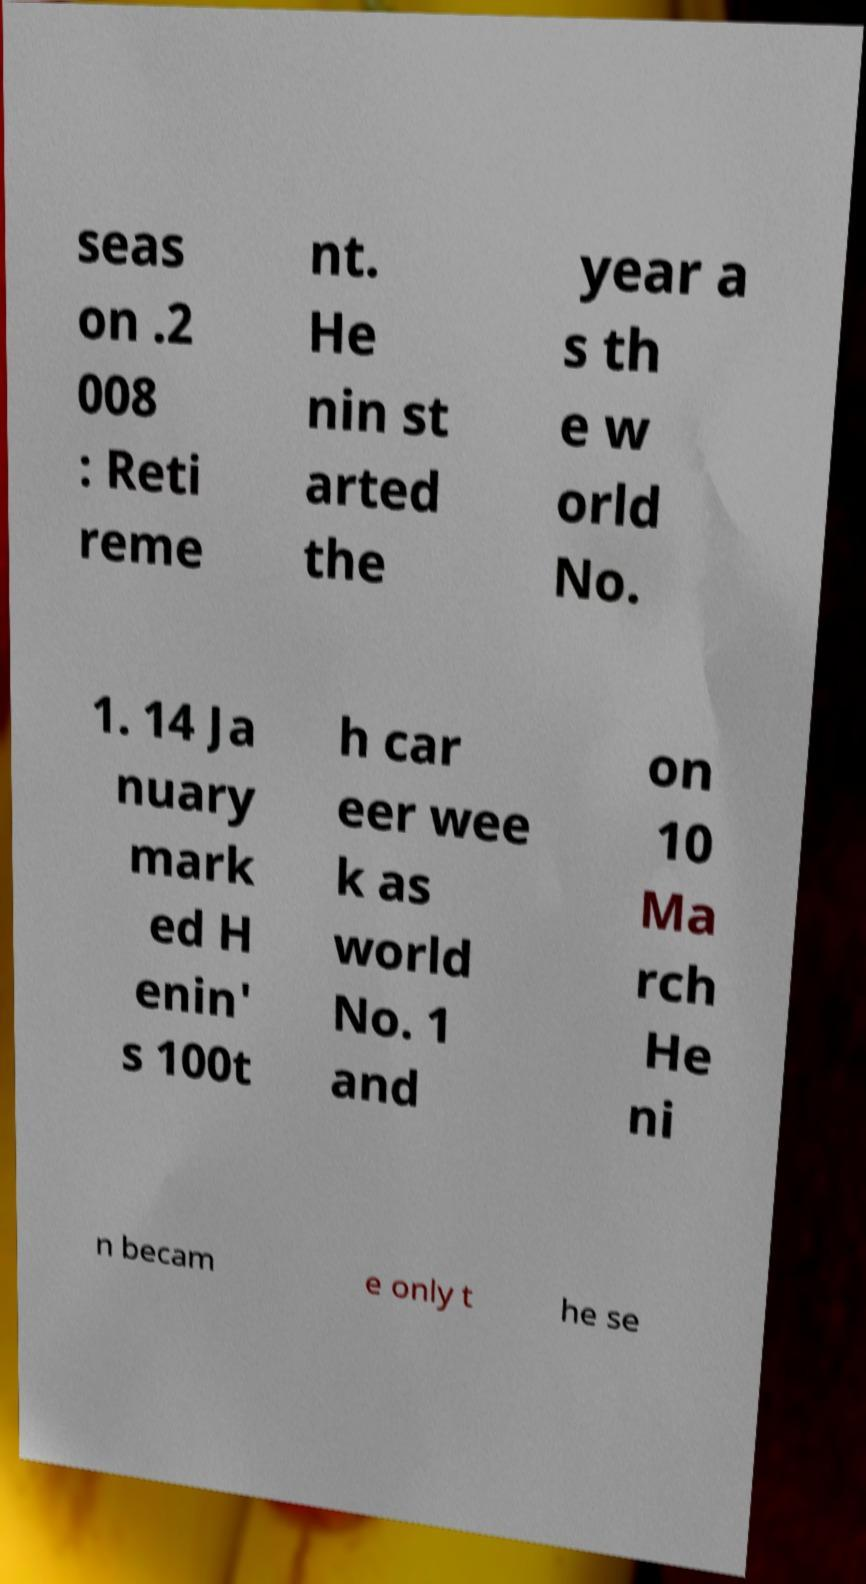What messages or text are displayed in this image? I need them in a readable, typed format. seas on .2 008 : Reti reme nt. He nin st arted the year a s th e w orld No. 1. 14 Ja nuary mark ed H enin' s 100t h car eer wee k as world No. 1 and on 10 Ma rch He ni n becam e only t he se 